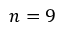Convert formula to latex. <formula><loc_0><loc_0><loc_500><loc_500>n = 9</formula> 